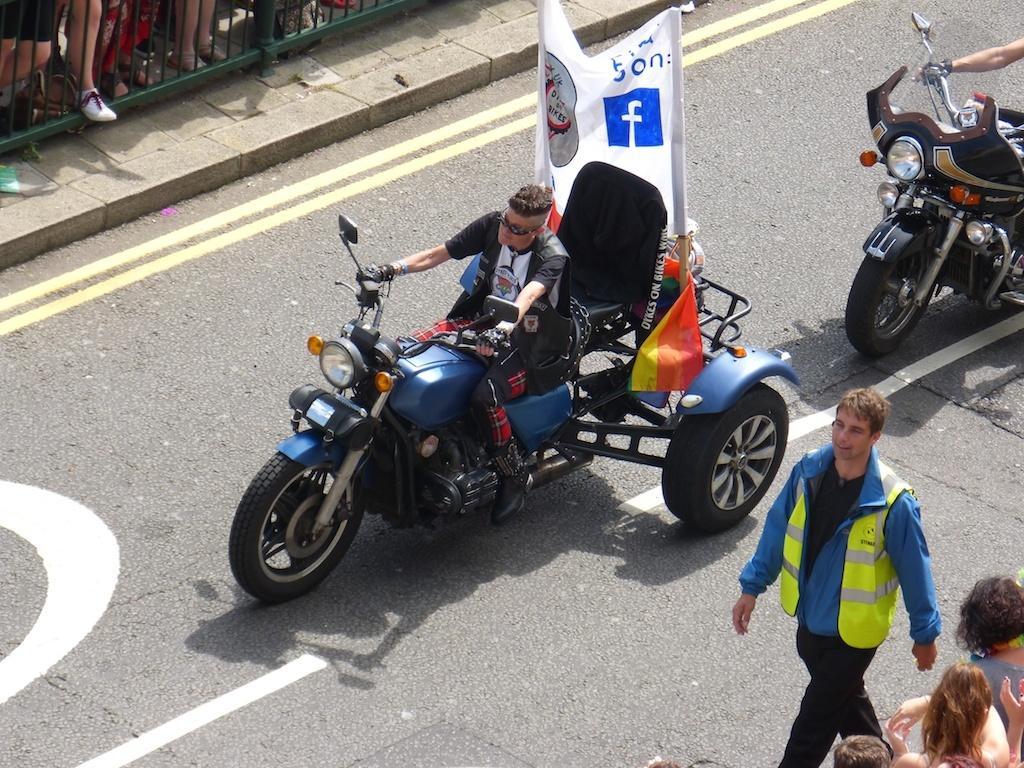How would you summarize this image in a sentence or two? In the foreground of the picture there are vehicles, people and road. At the top left corner we can see footpath, railing and people. 